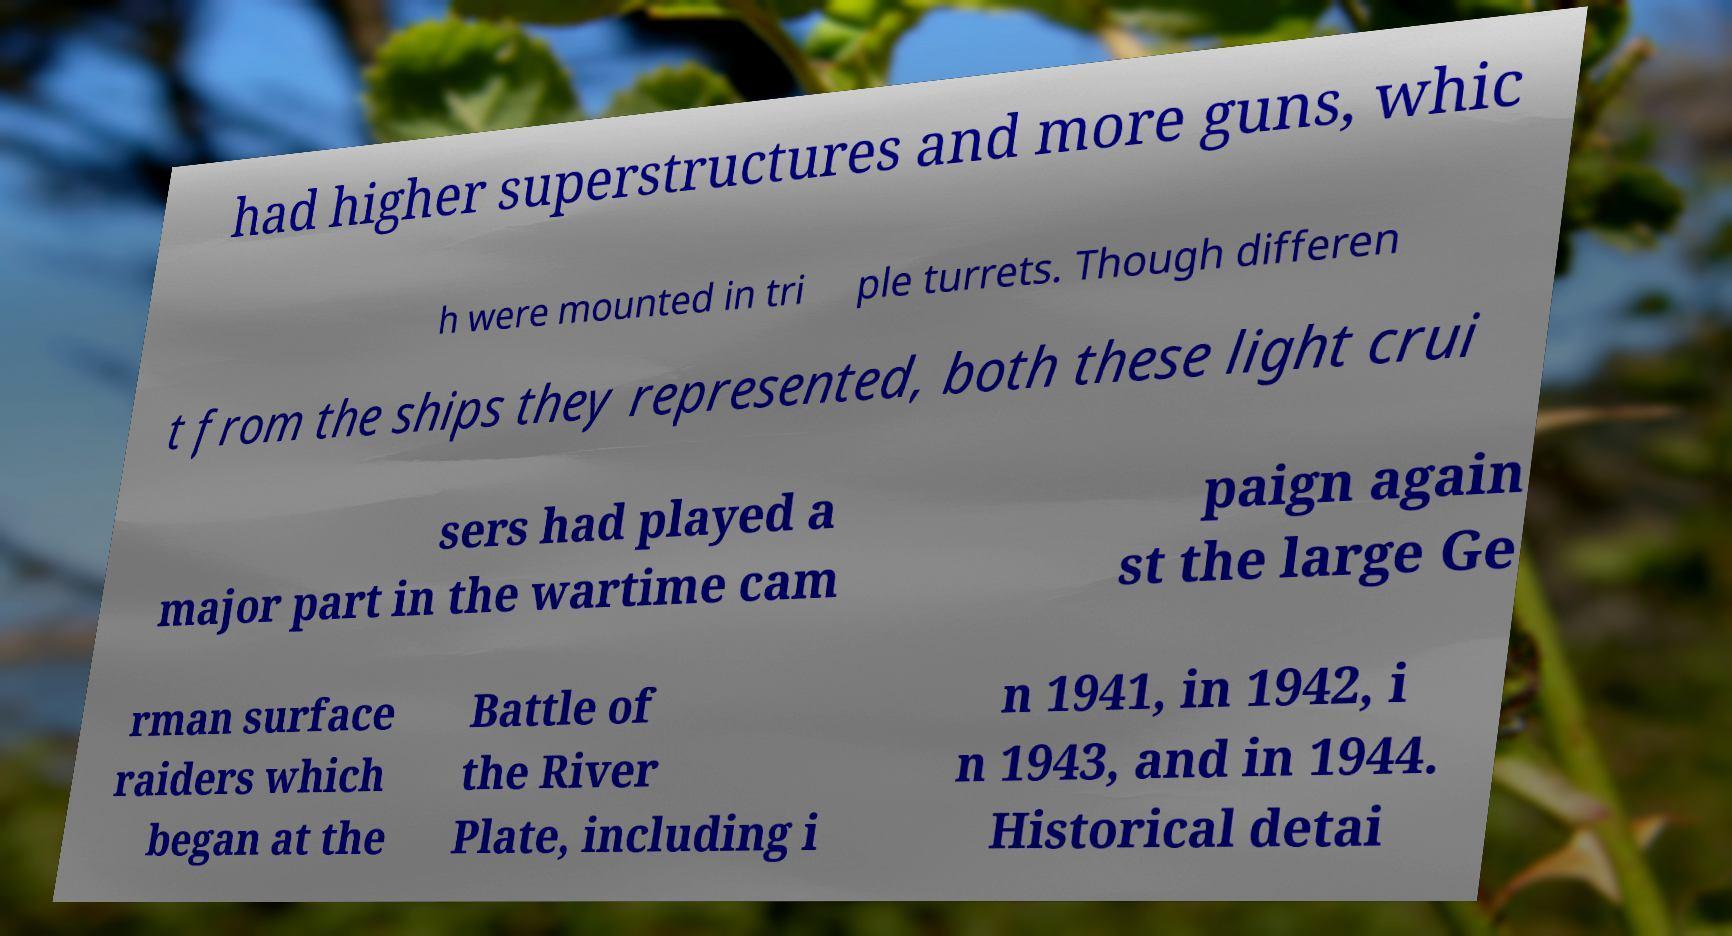Can you read and provide the text displayed in the image?This photo seems to have some interesting text. Can you extract and type it out for me? had higher superstructures and more guns, whic h were mounted in tri ple turrets. Though differen t from the ships they represented, both these light crui sers had played a major part in the wartime cam paign again st the large Ge rman surface raiders which began at the Battle of the River Plate, including i n 1941, in 1942, i n 1943, and in 1944. Historical detai 